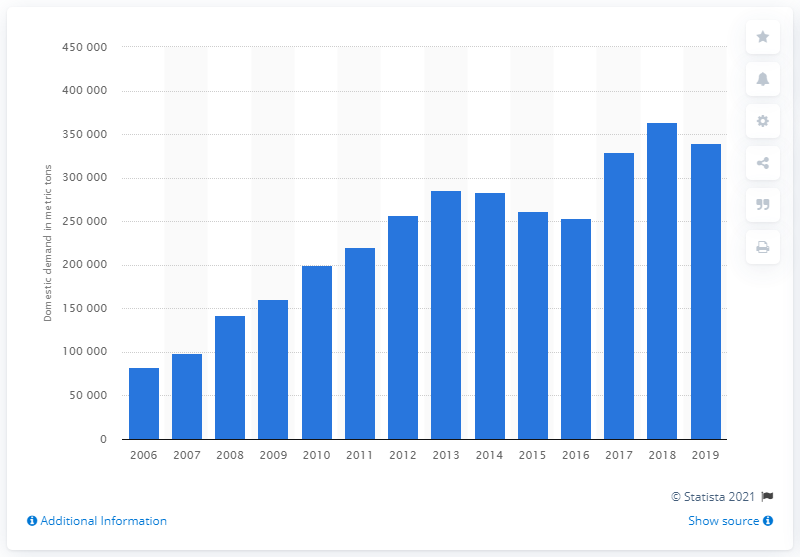Outline some significant characteristics in this image. The domestic demand for hydrogen peroxide in South Korea in 2019 was approximately 339,514 kilograms. 